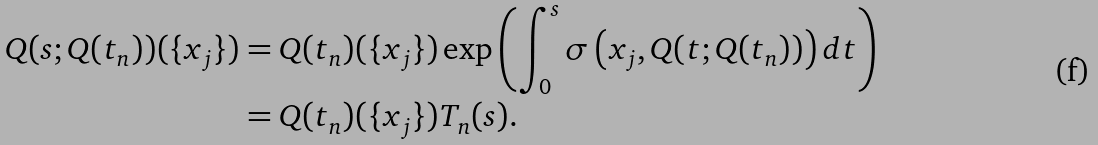<formula> <loc_0><loc_0><loc_500><loc_500>Q ( s ; Q ( t _ { n } ) ) ( \{ x _ { j } \} ) & = Q ( t _ { n } ) ( \{ x _ { j } \} ) \exp \left ( \int _ { 0 } ^ { s } \sigma \left ( x _ { j } , Q ( t ; Q ( t _ { n } ) ) \right ) d t \right ) \\ & = Q ( t _ { n } ) ( \{ x _ { j } \} ) T _ { n } ( s ) .</formula> 